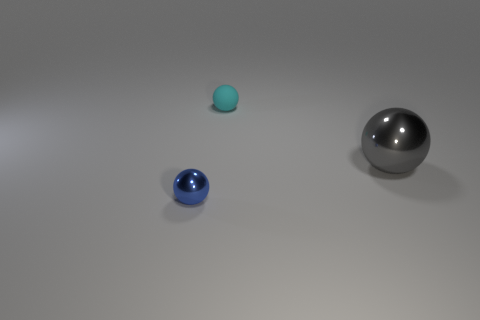Add 2 big blue rubber cylinders. How many objects exist? 5 Subtract all big gray things. Subtract all tiny objects. How many objects are left? 0 Add 3 tiny cyan matte balls. How many tiny cyan matte balls are left? 4 Add 1 big objects. How many big objects exist? 2 Subtract 0 yellow blocks. How many objects are left? 3 